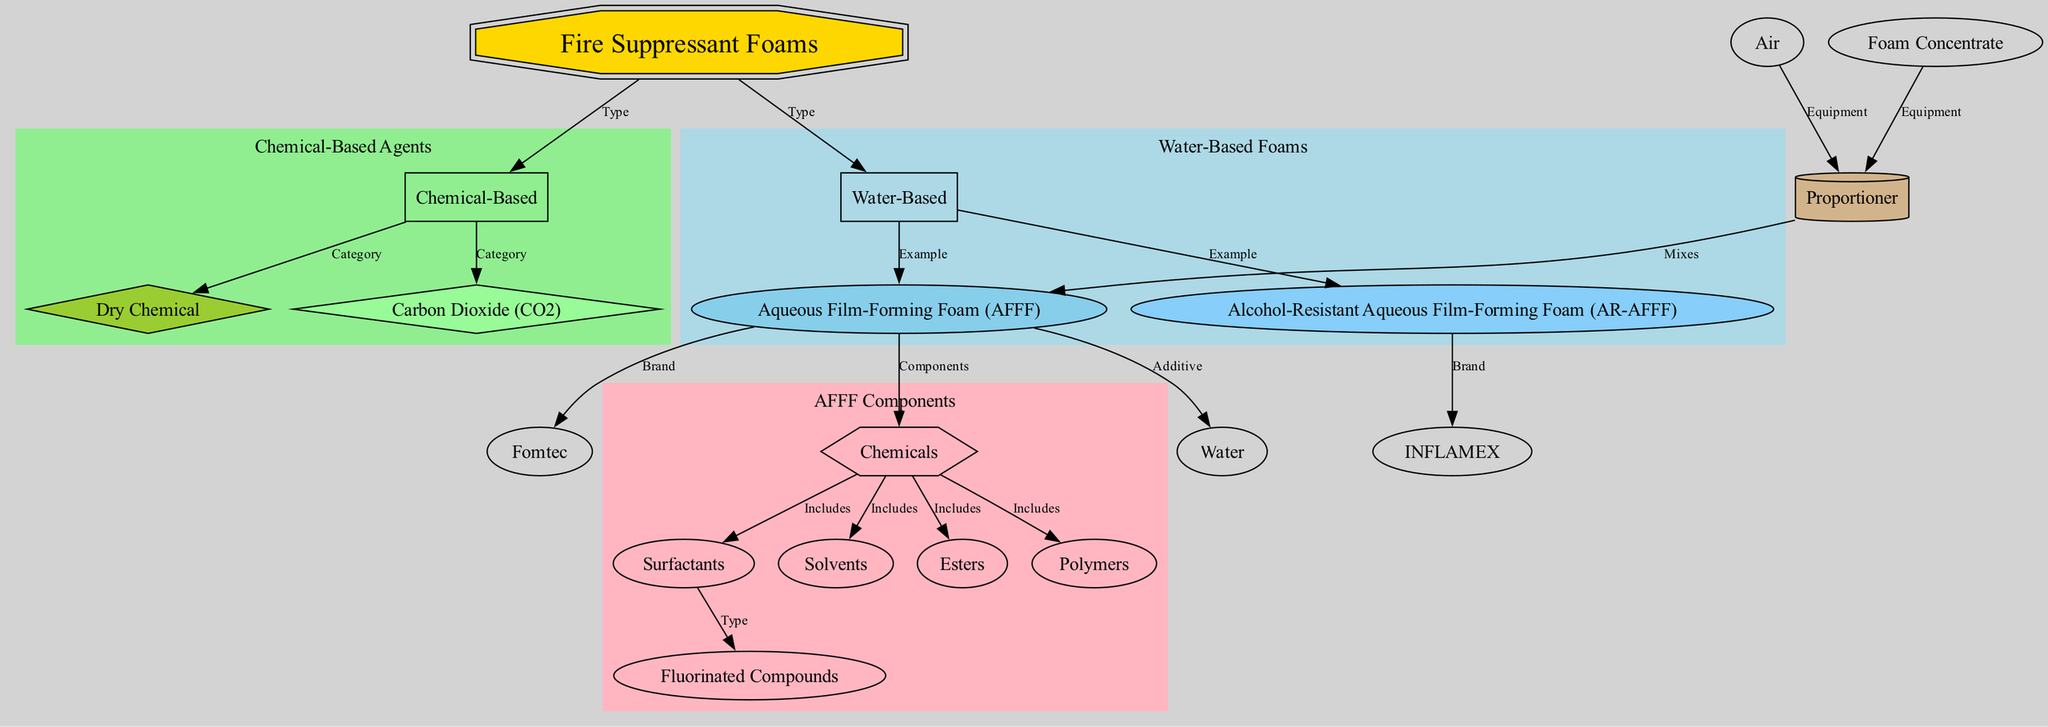What are the two main types of fire suppressant foams? The diagram shows two main types: "Water-Based" and "Chemical-Based" linked to "Fire Suppressant Foams."
Answer: Water-Based, Chemical-Based What is an example of a water-based foam? The diagram indicates that "AFFF" is one example of a "Water-Based" foam.
Answer: AFFF Which foam is associated with the brand "INFLAMEX"? The diagram connects "INFLAMEX" to "AR-AFFF," indicating that "AR-AFFF" is the foam associated with this brand.
Answer: AR-AFFF How many components are included under "Chemicals" in AFFF? The diagram lists five components: "Surfactants," "Solvents," "esters," "Polymers," and "Fluorinated compounds" that fall under "Chemicals."
Answer: 5 What is the relationship between "Foam Concentrate" and "Proportioner"? The diagram shows an edge labeled "Equipment" connecting "Foam Concentrate" to "Proportioner," indicating that these two are related in the context of firefighting equipment.
Answer: Equipment Which type of foam includes "Dry Chemical"? The diagram categorizes "Dry Chemical" under "Chemical-Based," showing that it belongs to that type of fire suppressant foam.
Answer: Chemical-Based What role does "Air" play in the use of "Proportioner"? The diagram shows an edge labeled "Equipment" connecting "Air" to "Proportioner," indicating that air is part of the equipment needed for the proportioner in firefighting systems.
Answer: Equipment How many examples of water-based foams are presented in the diagram? The diagram presents two examples under "Water-Based": "AFFF" and "AR-AFFF."
Answer: 2 